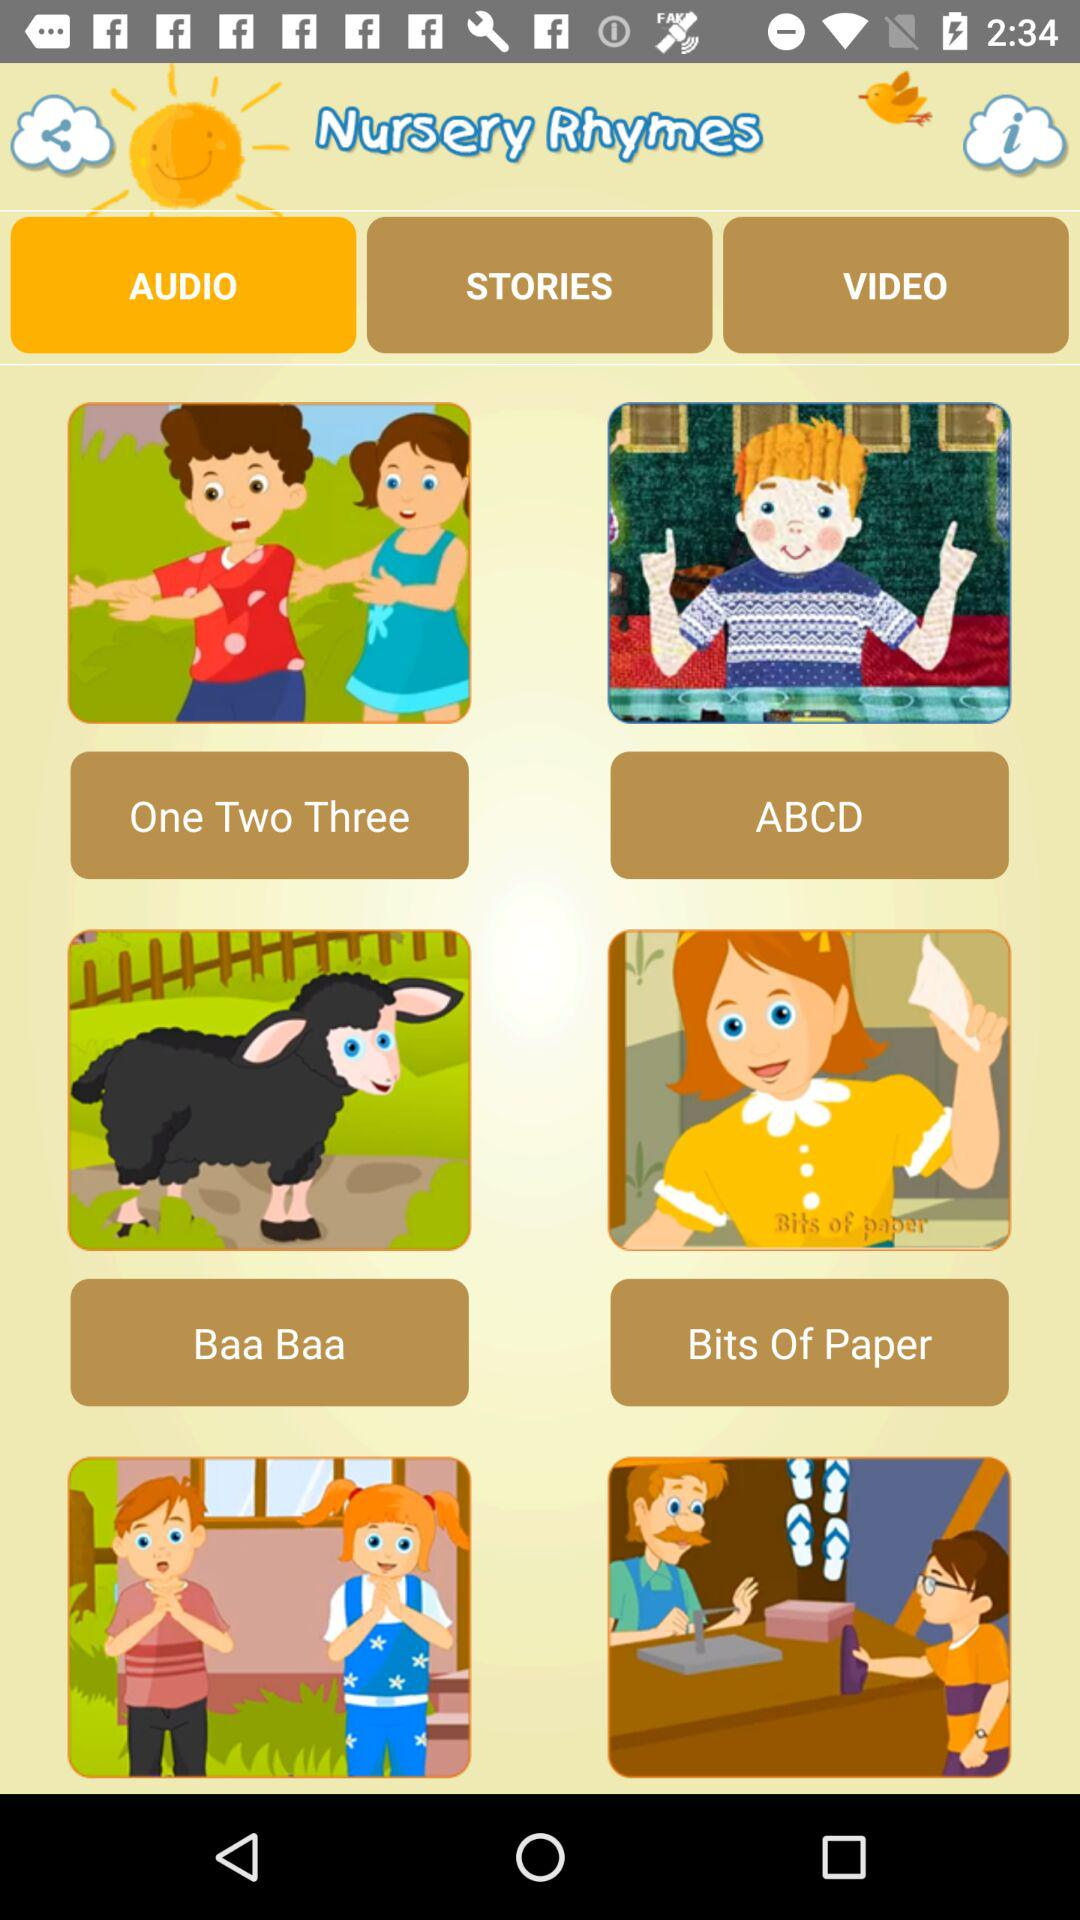Which option is selected? The selected option is "AUDIO". 